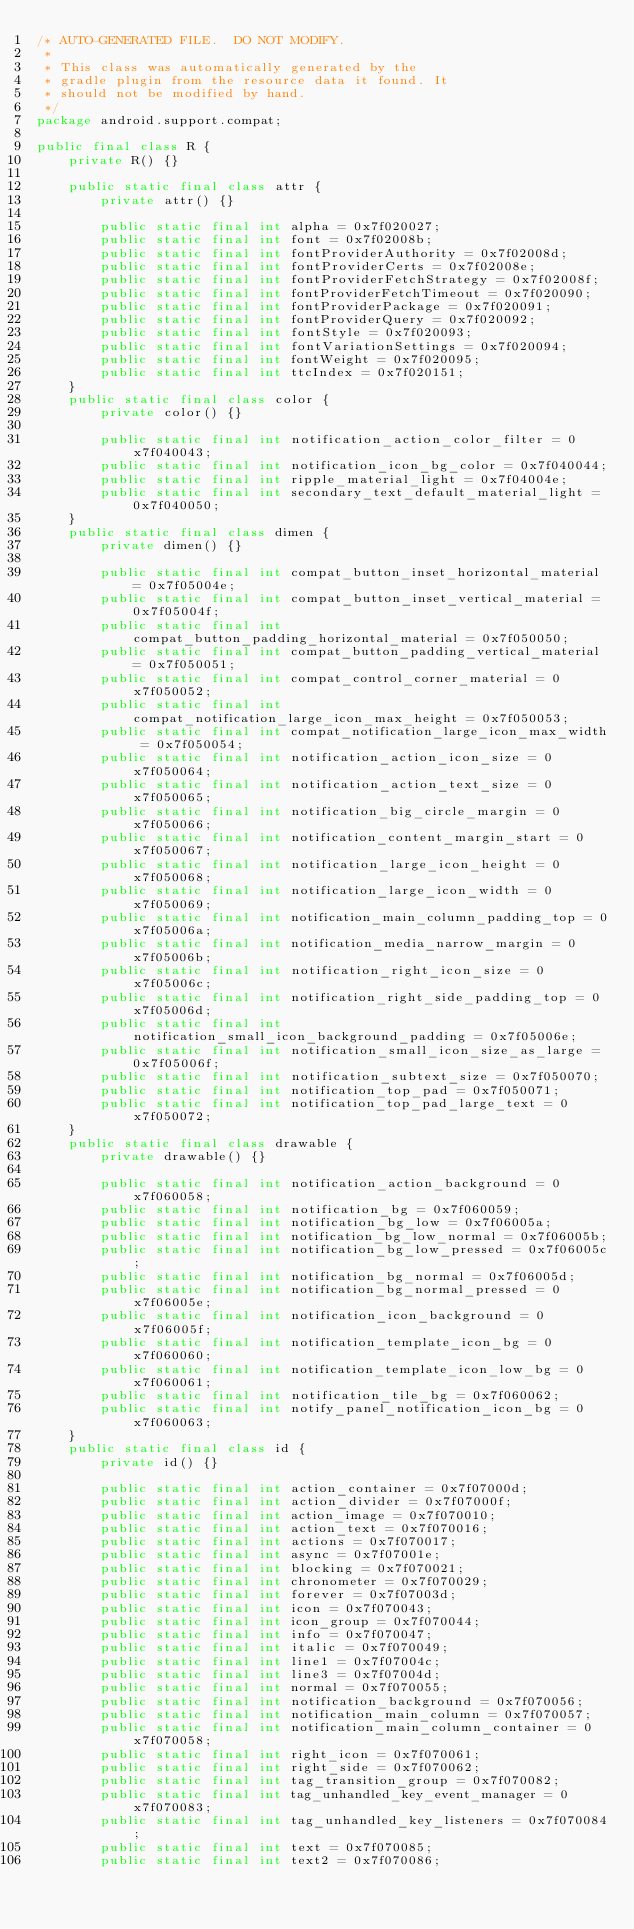<code> <loc_0><loc_0><loc_500><loc_500><_Java_>/* AUTO-GENERATED FILE.  DO NOT MODIFY.
 *
 * This class was automatically generated by the
 * gradle plugin from the resource data it found. It
 * should not be modified by hand.
 */
package android.support.compat;

public final class R {
    private R() {}

    public static final class attr {
        private attr() {}

        public static final int alpha = 0x7f020027;
        public static final int font = 0x7f02008b;
        public static final int fontProviderAuthority = 0x7f02008d;
        public static final int fontProviderCerts = 0x7f02008e;
        public static final int fontProviderFetchStrategy = 0x7f02008f;
        public static final int fontProviderFetchTimeout = 0x7f020090;
        public static final int fontProviderPackage = 0x7f020091;
        public static final int fontProviderQuery = 0x7f020092;
        public static final int fontStyle = 0x7f020093;
        public static final int fontVariationSettings = 0x7f020094;
        public static final int fontWeight = 0x7f020095;
        public static final int ttcIndex = 0x7f020151;
    }
    public static final class color {
        private color() {}

        public static final int notification_action_color_filter = 0x7f040043;
        public static final int notification_icon_bg_color = 0x7f040044;
        public static final int ripple_material_light = 0x7f04004e;
        public static final int secondary_text_default_material_light = 0x7f040050;
    }
    public static final class dimen {
        private dimen() {}

        public static final int compat_button_inset_horizontal_material = 0x7f05004e;
        public static final int compat_button_inset_vertical_material = 0x7f05004f;
        public static final int compat_button_padding_horizontal_material = 0x7f050050;
        public static final int compat_button_padding_vertical_material = 0x7f050051;
        public static final int compat_control_corner_material = 0x7f050052;
        public static final int compat_notification_large_icon_max_height = 0x7f050053;
        public static final int compat_notification_large_icon_max_width = 0x7f050054;
        public static final int notification_action_icon_size = 0x7f050064;
        public static final int notification_action_text_size = 0x7f050065;
        public static final int notification_big_circle_margin = 0x7f050066;
        public static final int notification_content_margin_start = 0x7f050067;
        public static final int notification_large_icon_height = 0x7f050068;
        public static final int notification_large_icon_width = 0x7f050069;
        public static final int notification_main_column_padding_top = 0x7f05006a;
        public static final int notification_media_narrow_margin = 0x7f05006b;
        public static final int notification_right_icon_size = 0x7f05006c;
        public static final int notification_right_side_padding_top = 0x7f05006d;
        public static final int notification_small_icon_background_padding = 0x7f05006e;
        public static final int notification_small_icon_size_as_large = 0x7f05006f;
        public static final int notification_subtext_size = 0x7f050070;
        public static final int notification_top_pad = 0x7f050071;
        public static final int notification_top_pad_large_text = 0x7f050072;
    }
    public static final class drawable {
        private drawable() {}

        public static final int notification_action_background = 0x7f060058;
        public static final int notification_bg = 0x7f060059;
        public static final int notification_bg_low = 0x7f06005a;
        public static final int notification_bg_low_normal = 0x7f06005b;
        public static final int notification_bg_low_pressed = 0x7f06005c;
        public static final int notification_bg_normal = 0x7f06005d;
        public static final int notification_bg_normal_pressed = 0x7f06005e;
        public static final int notification_icon_background = 0x7f06005f;
        public static final int notification_template_icon_bg = 0x7f060060;
        public static final int notification_template_icon_low_bg = 0x7f060061;
        public static final int notification_tile_bg = 0x7f060062;
        public static final int notify_panel_notification_icon_bg = 0x7f060063;
    }
    public static final class id {
        private id() {}

        public static final int action_container = 0x7f07000d;
        public static final int action_divider = 0x7f07000f;
        public static final int action_image = 0x7f070010;
        public static final int action_text = 0x7f070016;
        public static final int actions = 0x7f070017;
        public static final int async = 0x7f07001e;
        public static final int blocking = 0x7f070021;
        public static final int chronometer = 0x7f070029;
        public static final int forever = 0x7f07003d;
        public static final int icon = 0x7f070043;
        public static final int icon_group = 0x7f070044;
        public static final int info = 0x7f070047;
        public static final int italic = 0x7f070049;
        public static final int line1 = 0x7f07004c;
        public static final int line3 = 0x7f07004d;
        public static final int normal = 0x7f070055;
        public static final int notification_background = 0x7f070056;
        public static final int notification_main_column = 0x7f070057;
        public static final int notification_main_column_container = 0x7f070058;
        public static final int right_icon = 0x7f070061;
        public static final int right_side = 0x7f070062;
        public static final int tag_transition_group = 0x7f070082;
        public static final int tag_unhandled_key_event_manager = 0x7f070083;
        public static final int tag_unhandled_key_listeners = 0x7f070084;
        public static final int text = 0x7f070085;
        public static final int text2 = 0x7f070086;</code> 